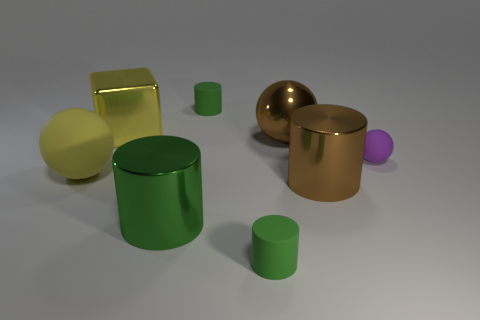There is a green cylinder that is right of the tiny cylinder behind the yellow metallic thing; what is its size?
Provide a short and direct response. Small. There is a object that is the same color as the metallic ball; what is its size?
Offer a very short reply. Large. How many other things are the same size as the shiny cube?
Give a very brief answer. 4. What number of big brown shiny balls are there?
Offer a terse response. 1. Is the brown ball the same size as the metal block?
Ensure brevity in your answer.  Yes. How many other objects are the same shape as the large matte thing?
Ensure brevity in your answer.  2. There is a small thing that is in front of the yellow thing in front of the tiny rubber sphere; what is it made of?
Your answer should be compact. Rubber. There is a purple object; are there any green things on the right side of it?
Ensure brevity in your answer.  No. Is the size of the yellow metallic object the same as the sphere on the right side of the brown shiny ball?
Make the answer very short. No. What is the size of the yellow rubber object that is the same shape as the purple rubber thing?
Offer a terse response. Large. 